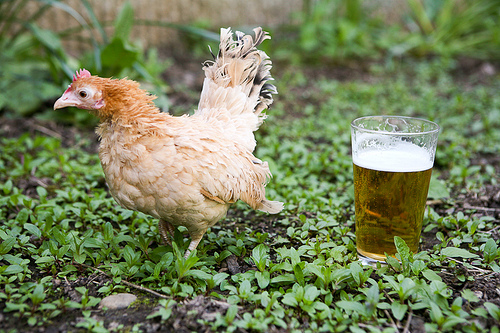<image>
Can you confirm if the chicken is to the left of the beer? Yes. From this viewpoint, the chicken is positioned to the left side relative to the beer. 